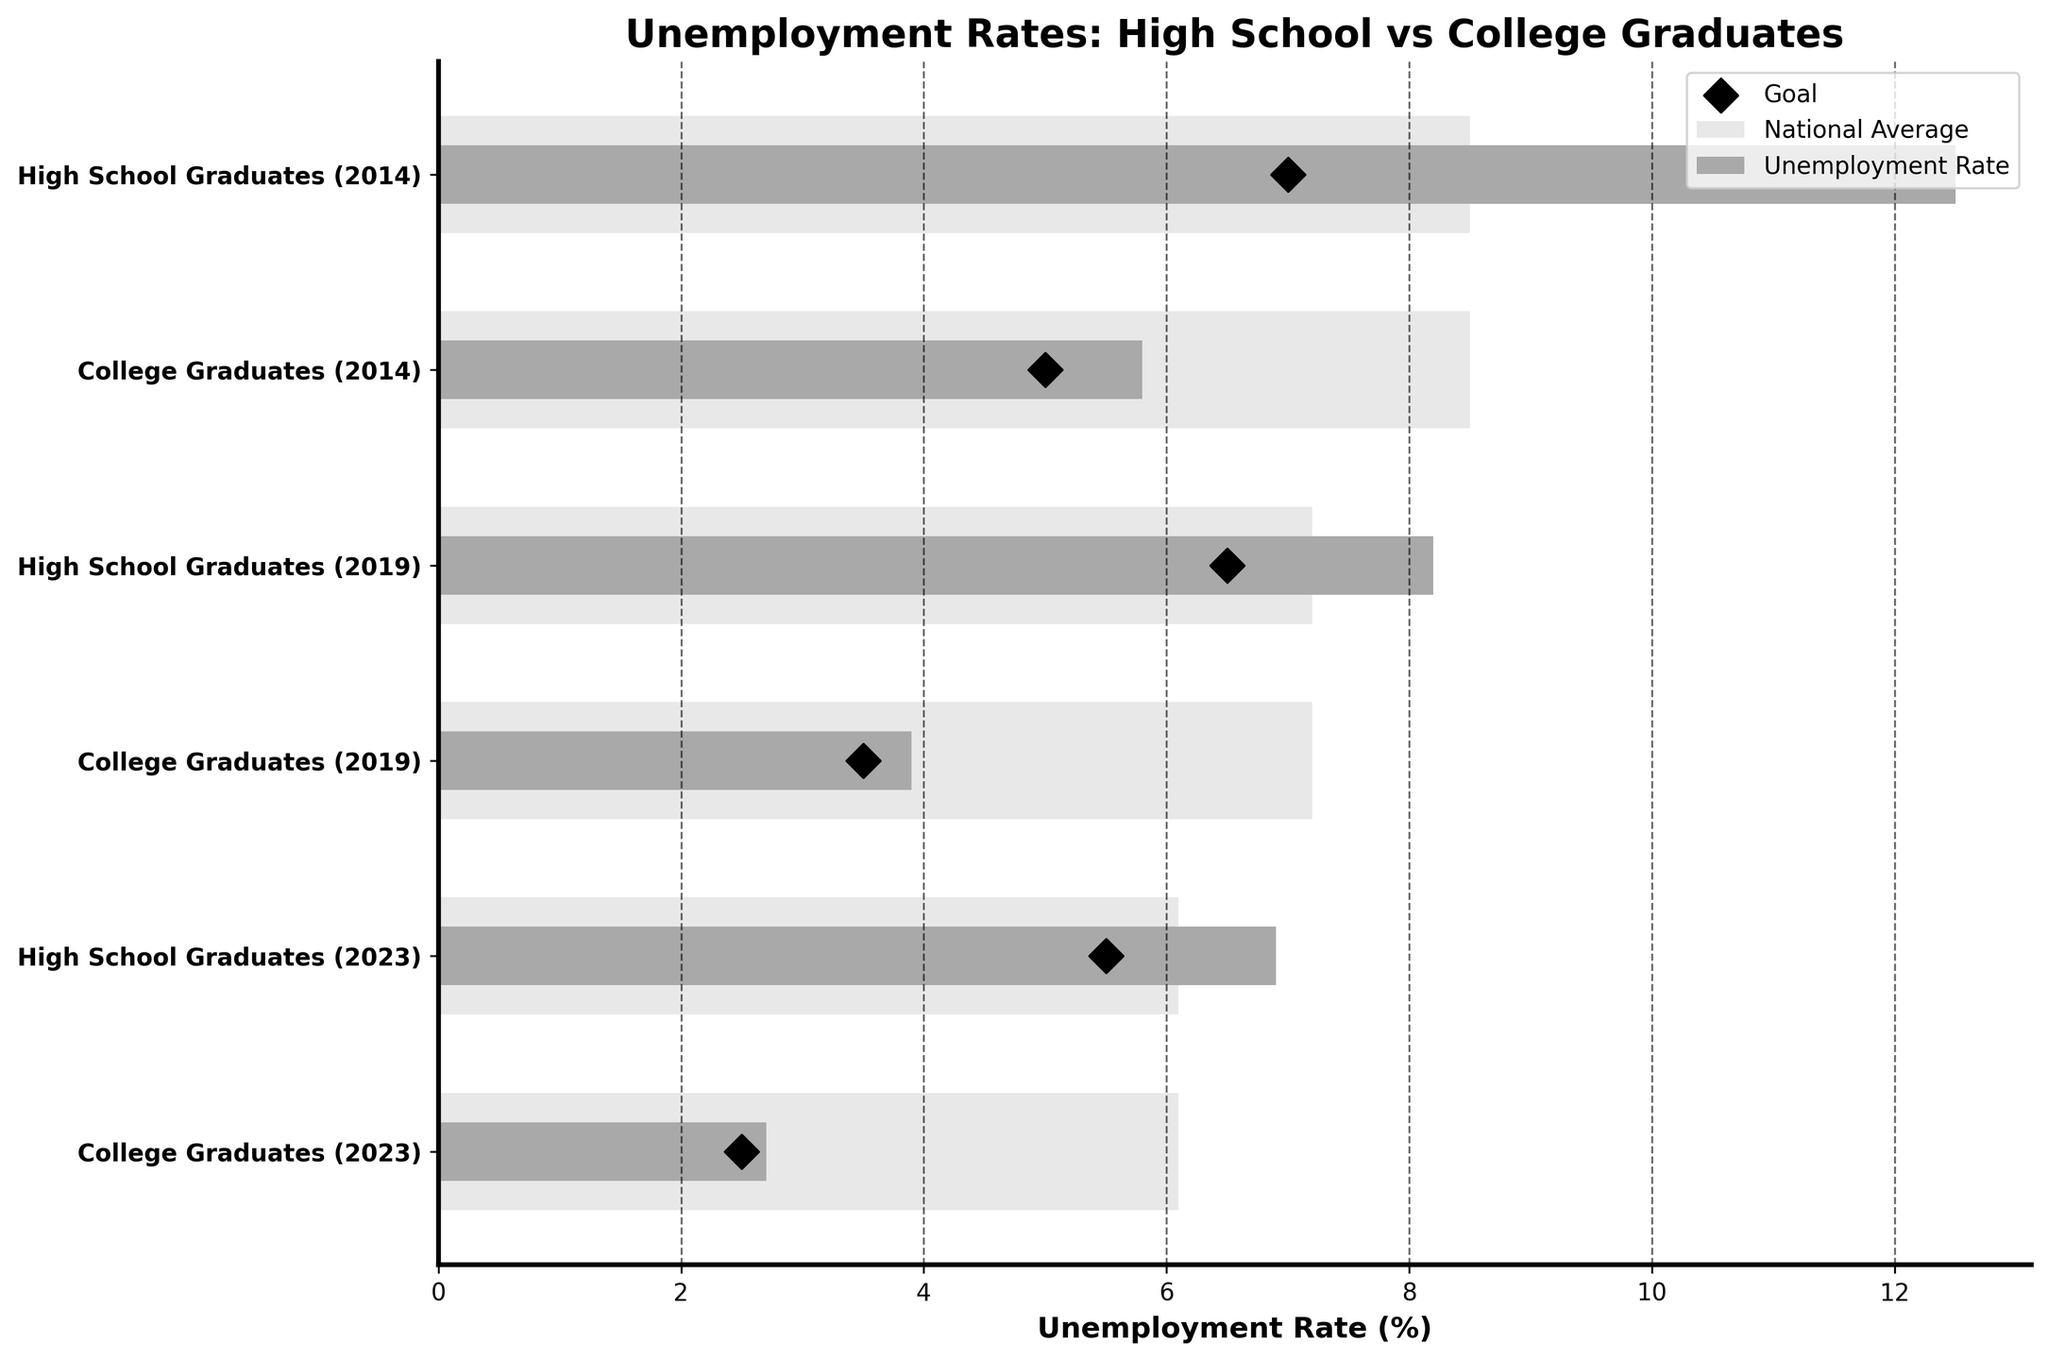What is the title of the plot? The title is displayed at the top of the plot. You can see it written in bold text.
Answer: Unemployment Rates: High School vs College Graduates Which category has the highest unemployment rate in 2014? The highest bar in 2014 indicates the category with the highest unemployment rate.
Answer: High School Graduates What is the goal unemployment rate for college graduates in 2023? The goal is represented by the black diamond marker, aligned with the "College Graduates (2023)" category.
Answer: 2.5% How does the unemployment rate for high school graduates in 2014 compare to the national average of that year? By inspecting the lengths of the bars corresponding to "High School Graduates (2014)" and the national average line, we can see how the specific unemployment rate compares to the national average for that year.
Answer: Higher What is the difference in the unemployment rates between high school and college graduates in 2019? Subtract the unemployment rate of "College Graduates (2019)" from that of "High School Graduates (2019)".
Answer: 4.3% In which year did high school graduates have the closest unemployment rate to their goal? Compare the distance between the bar and the black diamond marker for each year within the "High School Graduates" category.
Answer: 2023 Which category had the most improvement in unemployment rate from 2014 to 2023? Calculate the difference in unemployment rates between 2014 and 2023 for each category and find the one with the largest difference.
Answer: High School Graduates Is there any year where the unemployment rate for high school graduates was below the national average? Compare the bars representing the unemployment rates for "High School Graduates" with the corresponding national average bars for each year.
Answer: No Do the goals for college graduates' unemployment rates decrease or increase over the years? Look at the positions of the black diamond markers for the "College Graduates" category across years and determine the trend.
Answer: Decrease How much lower is the college graduates' unemployment rate compared to high school graduates' in 2023? Subtract the unemployment rate of "College Graduates (2023)" from that of "High School Graduates (2023)".
Answer: 4.2% 